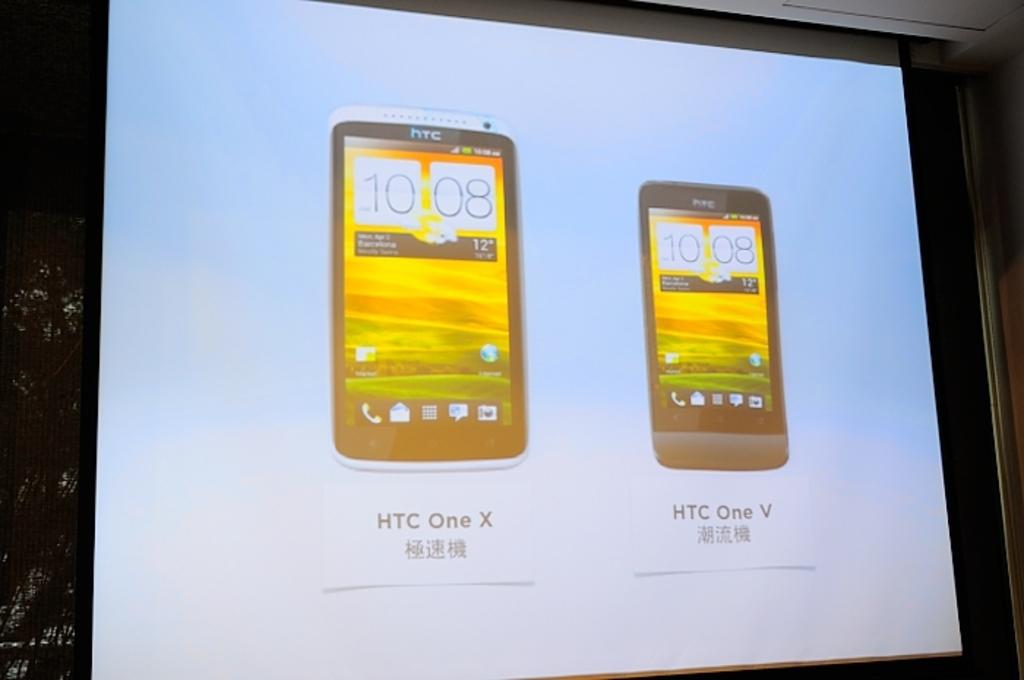<image>
Create a compact narrative representing the image presented. a projection screen that says 'htc one x' on part of it 